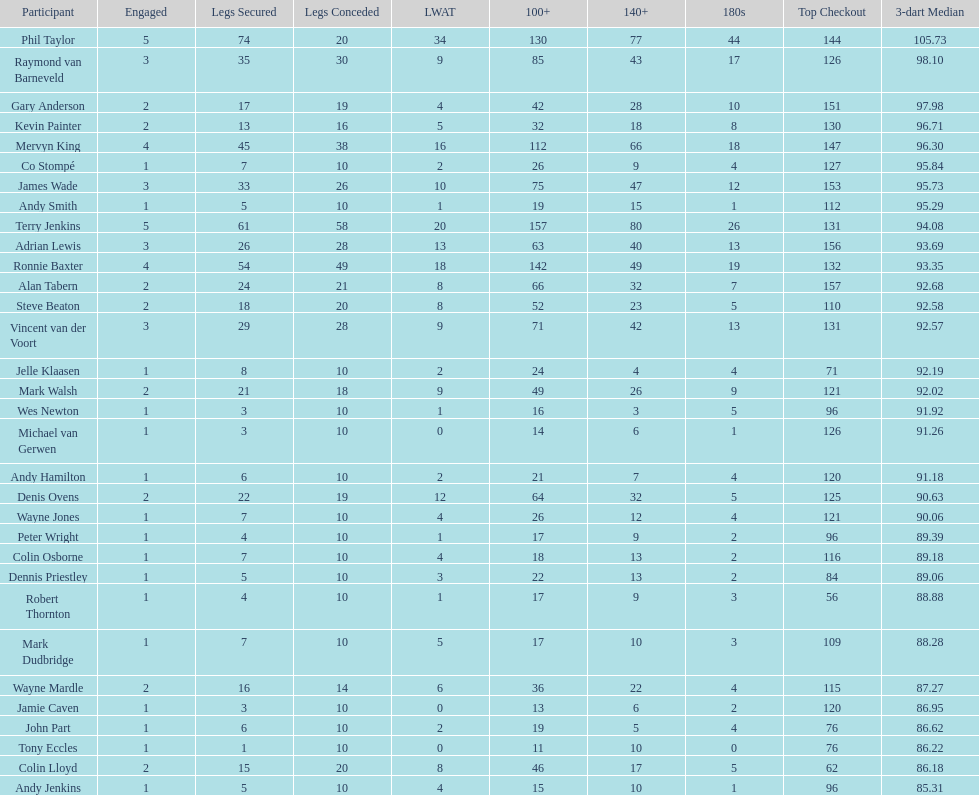What is the name of the next player after mark walsh? Wes Newton. 